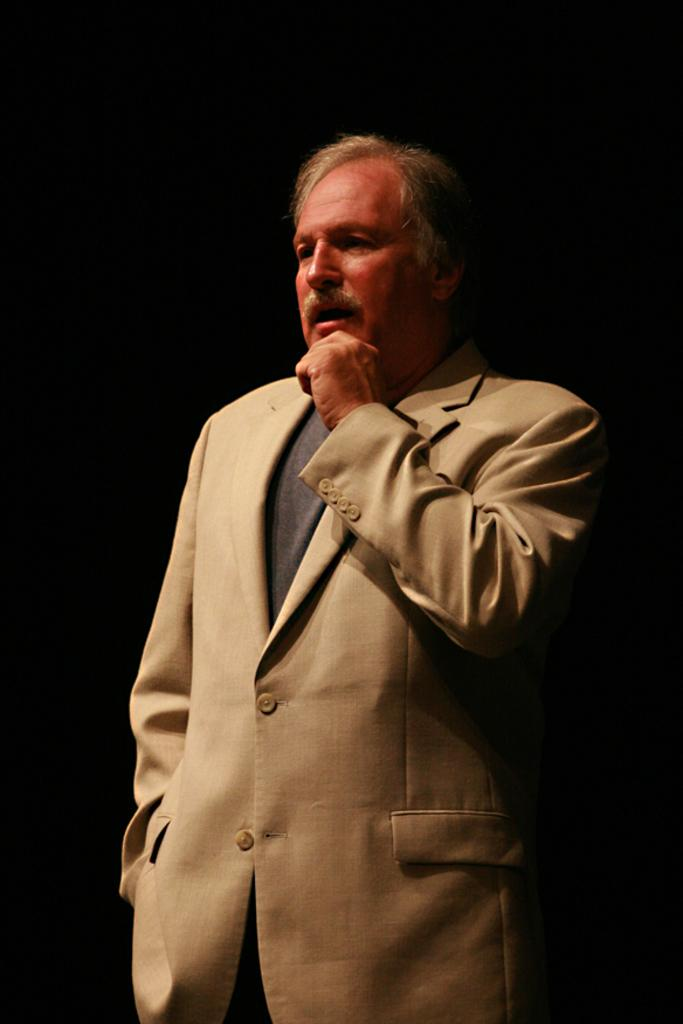What is the main subject of the image? The main subject of the image is a person standing. What is the person wearing in the image? The person is wearing a suit in the image. What is the color of the background in the image? The background of the image is black. What type of soda is the person holding in the image? There is no soda present in the image, and the person is not holding any beverage. What language is the person speaking in the image? The image does not provide any information about the language being spoken. 